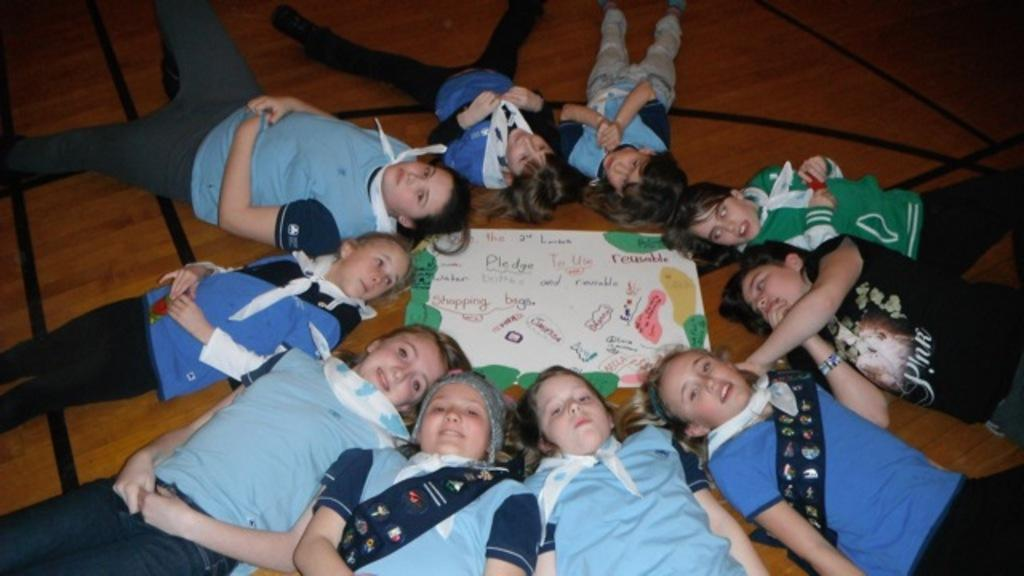Who or what can be seen in the image? There are people in the image. What are the people doing in the image? The people are lying on a wooden surface. Is there anything else visible in the image besides the people? Yes, there is a poster in the image. What type of sheet is covering the people in the image? There is no sheet covering the people in the image; they are lying directly on the wooden surface. What are the people writing on in the image? The provided facts do not mention any writing or writing materials in the image. 